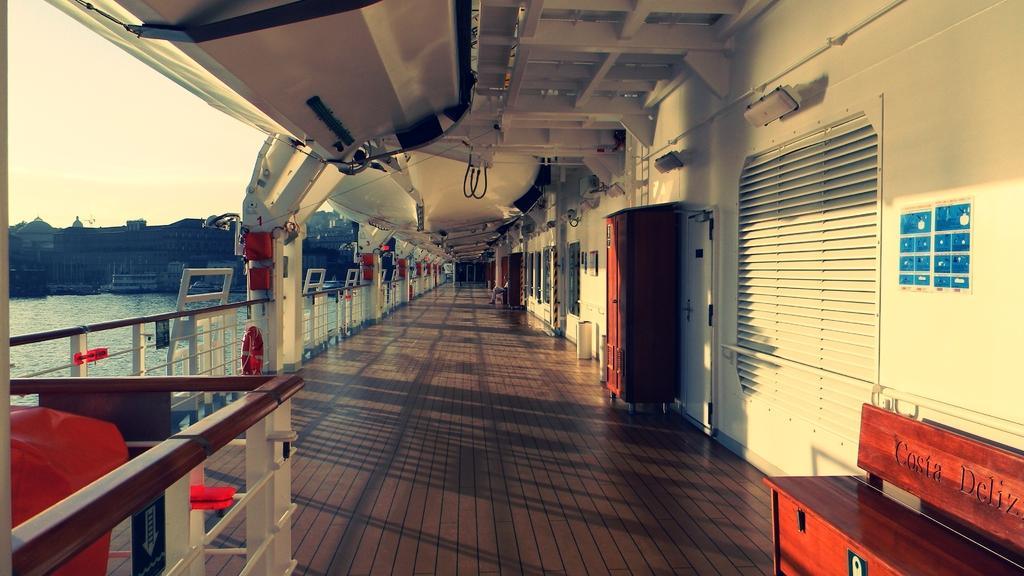Can you describe this image briefly? In this image we can see a wooden floor, railing, lights and cupboards to the wall. Here we can also see the ceiling or roof. In the background, we can see water, buildings and the sky. 